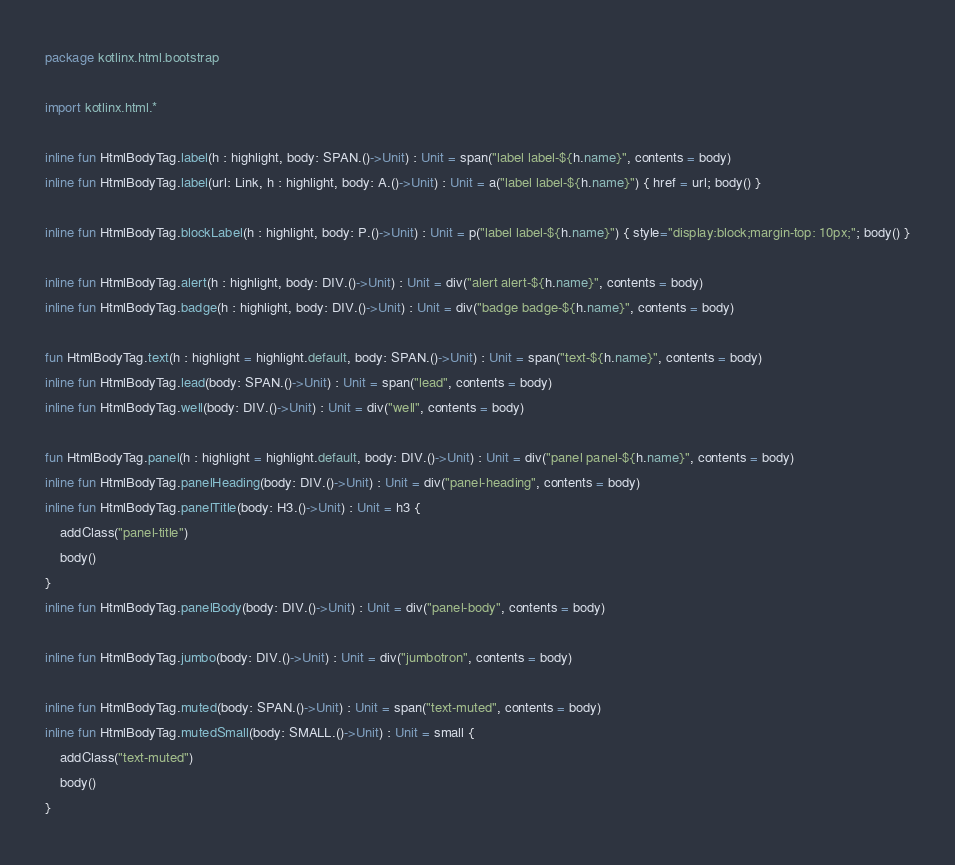Convert code to text. <code><loc_0><loc_0><loc_500><loc_500><_Kotlin_>package kotlinx.html.bootstrap

import kotlinx.html.*

inline fun HtmlBodyTag.label(h : highlight, body: SPAN.()->Unit) : Unit = span("label label-${h.name}", contents = body)
inline fun HtmlBodyTag.label(url: Link, h : highlight, body: A.()->Unit) : Unit = a("label label-${h.name}") { href = url; body() }

inline fun HtmlBodyTag.blockLabel(h : highlight, body: P.()->Unit) : Unit = p("label label-${h.name}") { style="display:block;margin-top: 10px;"; body() }

inline fun HtmlBodyTag.alert(h : highlight, body: DIV.()->Unit) : Unit = div("alert alert-${h.name}", contents = body)
inline fun HtmlBodyTag.badge(h : highlight, body: DIV.()->Unit) : Unit = div("badge badge-${h.name}", contents = body)

fun HtmlBodyTag.text(h : highlight = highlight.default, body: SPAN.()->Unit) : Unit = span("text-${h.name}", contents = body)
inline fun HtmlBodyTag.lead(body: SPAN.()->Unit) : Unit = span("lead", contents = body)
inline fun HtmlBodyTag.well(body: DIV.()->Unit) : Unit = div("well", contents = body)

fun HtmlBodyTag.panel(h : highlight = highlight.default, body: DIV.()->Unit) : Unit = div("panel panel-${h.name}", contents = body)
inline fun HtmlBodyTag.panelHeading(body: DIV.()->Unit) : Unit = div("panel-heading", contents = body)
inline fun HtmlBodyTag.panelTitle(body: H3.()->Unit) : Unit = h3 {
    addClass("panel-title")
    body()
}
inline fun HtmlBodyTag.panelBody(body: DIV.()->Unit) : Unit = div("panel-body", contents = body)

inline fun HtmlBodyTag.jumbo(body: DIV.()->Unit) : Unit = div("jumbotron", contents = body)

inline fun HtmlBodyTag.muted(body: SPAN.()->Unit) : Unit = span("text-muted", contents = body)
inline fun HtmlBodyTag.mutedSmall(body: SMALL.()->Unit) : Unit = small {
    addClass("text-muted")
    body()
}


</code> 